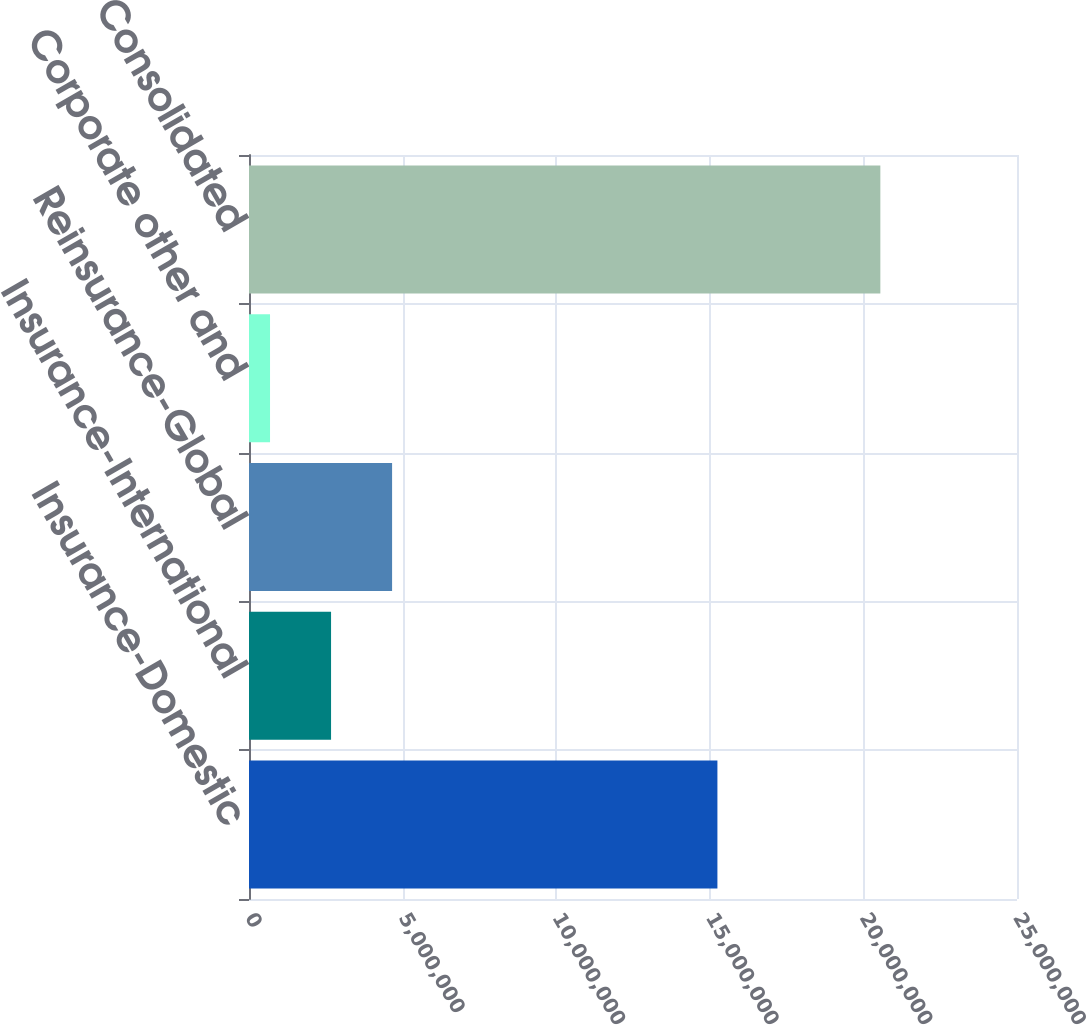<chart> <loc_0><loc_0><loc_500><loc_500><bar_chart><fcel>Insurance-Domestic<fcel>Insurance-International<fcel>Reinsurance-Global<fcel>Corporate other and<fcel>Consolidated<nl><fcel>1.52478e+07<fcel>2.67122e+06<fcel>4.65795e+06<fcel>684486<fcel>2.05518e+07<nl></chart> 